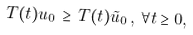<formula> <loc_0><loc_0><loc_500><loc_500>T ( t ) u _ { 0 } \, \geq \, T ( t ) \tilde { u } _ { 0 } \, , \, \forall t \geq 0 ,</formula> 